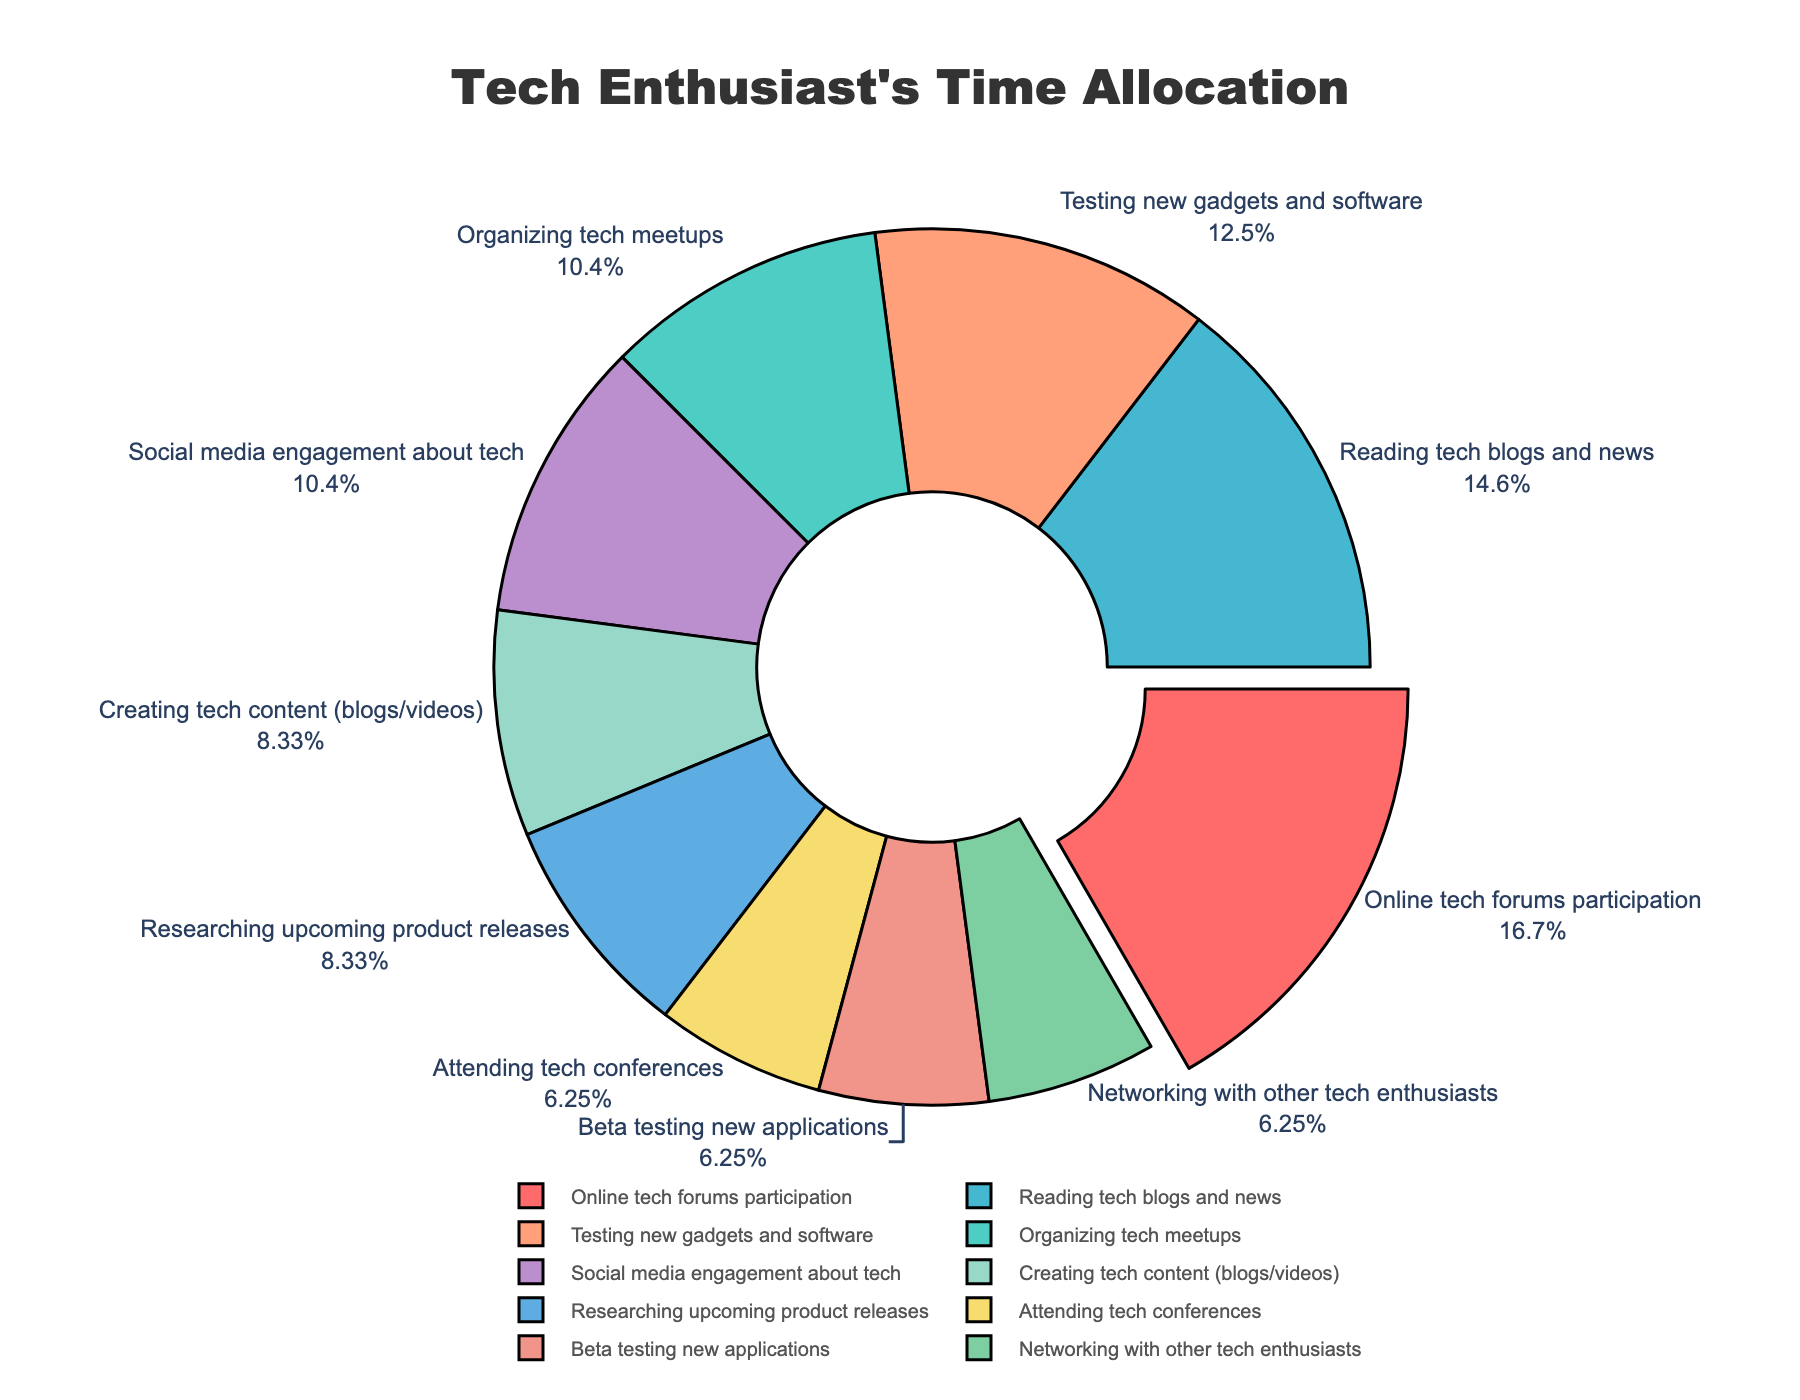how much total time is spent on creating tech content and researching upcoming product releases? Adding the hours together: 4 hours (creating tech content) + 4 hours (researching upcoming product releases) = 8 hours
Answer: 8 hours Which activity takes up the highest percentage of the tech enthusiasts' time? The activity with the largest pull and highest value is "Online tech forums participation" which is visually separated more prominently.
Answer: Online tech forums participation Compare the time spent on organizing tech meetups and attending tech conferences. Organizing tech meetups takes 5 hours per week and attending tech conferences takes 3 hours per week. 5 is greater than 3.
Answer: Organizing tech meetups What percentage of time is spent on beta testing new applications? The pie chart shows text information outside the slice, where beta testing new applications is shown with its percentage.
Answer: 8.57% What is the combined percentage of time spent on social media engagement about tech and networking with other tech enthusiasts? Adding the percentages together; Social media engagement about tech (14.29%) + Networking with other tech enthusiasts (8.57%) = 22.86%
Answer: 22.86% What color represents the activity "Testing new gadgets and software"? The slice labeled "Testing new gadgets and software" is filled with the color blue.
Answer: Blue How many activities take up less than 10% of the time each? Identify and count the slices with percentages shown to be less than 10%: Attending tech conferences, Beta testing new applications, and Networking with other tech enthusiasts.
Answer: 3 What is the average time spent on attending tech conferences, beta testing new applications, and networking with other tech enthusiasts? Adding the hours and dividing by the number of activities; (3 + 3 + 3)/3 = 3 hours on average.
Answer: 3 hours Which activity is represented by the red slice and how much time is spent on it? The red slice representing "Online tech forums participation" takes 8 hours per week.
Answer: Online tech forums participation, 8 hours 